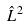<formula> <loc_0><loc_0><loc_500><loc_500>\hat { L } ^ { 2 }</formula> 